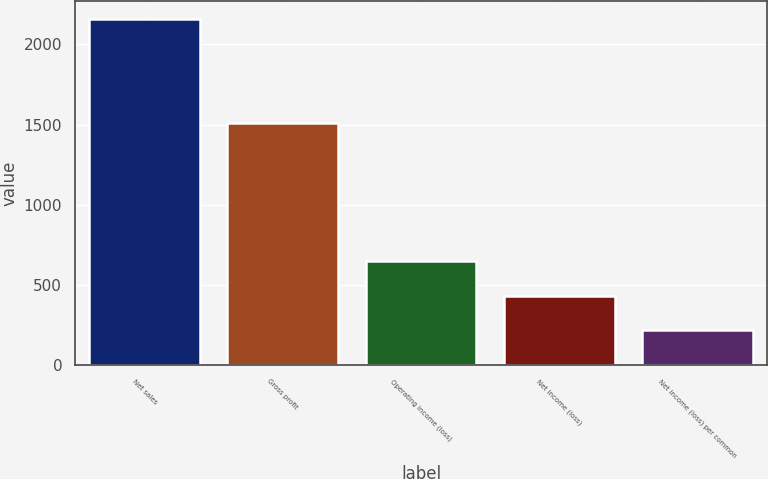<chart> <loc_0><loc_0><loc_500><loc_500><bar_chart><fcel>Net sales<fcel>Gross profit<fcel>Operating income (loss)<fcel>Net income (loss)<fcel>Net income (loss) per common<nl><fcel>2160<fcel>1510<fcel>648.15<fcel>432.17<fcel>216.19<nl></chart> 